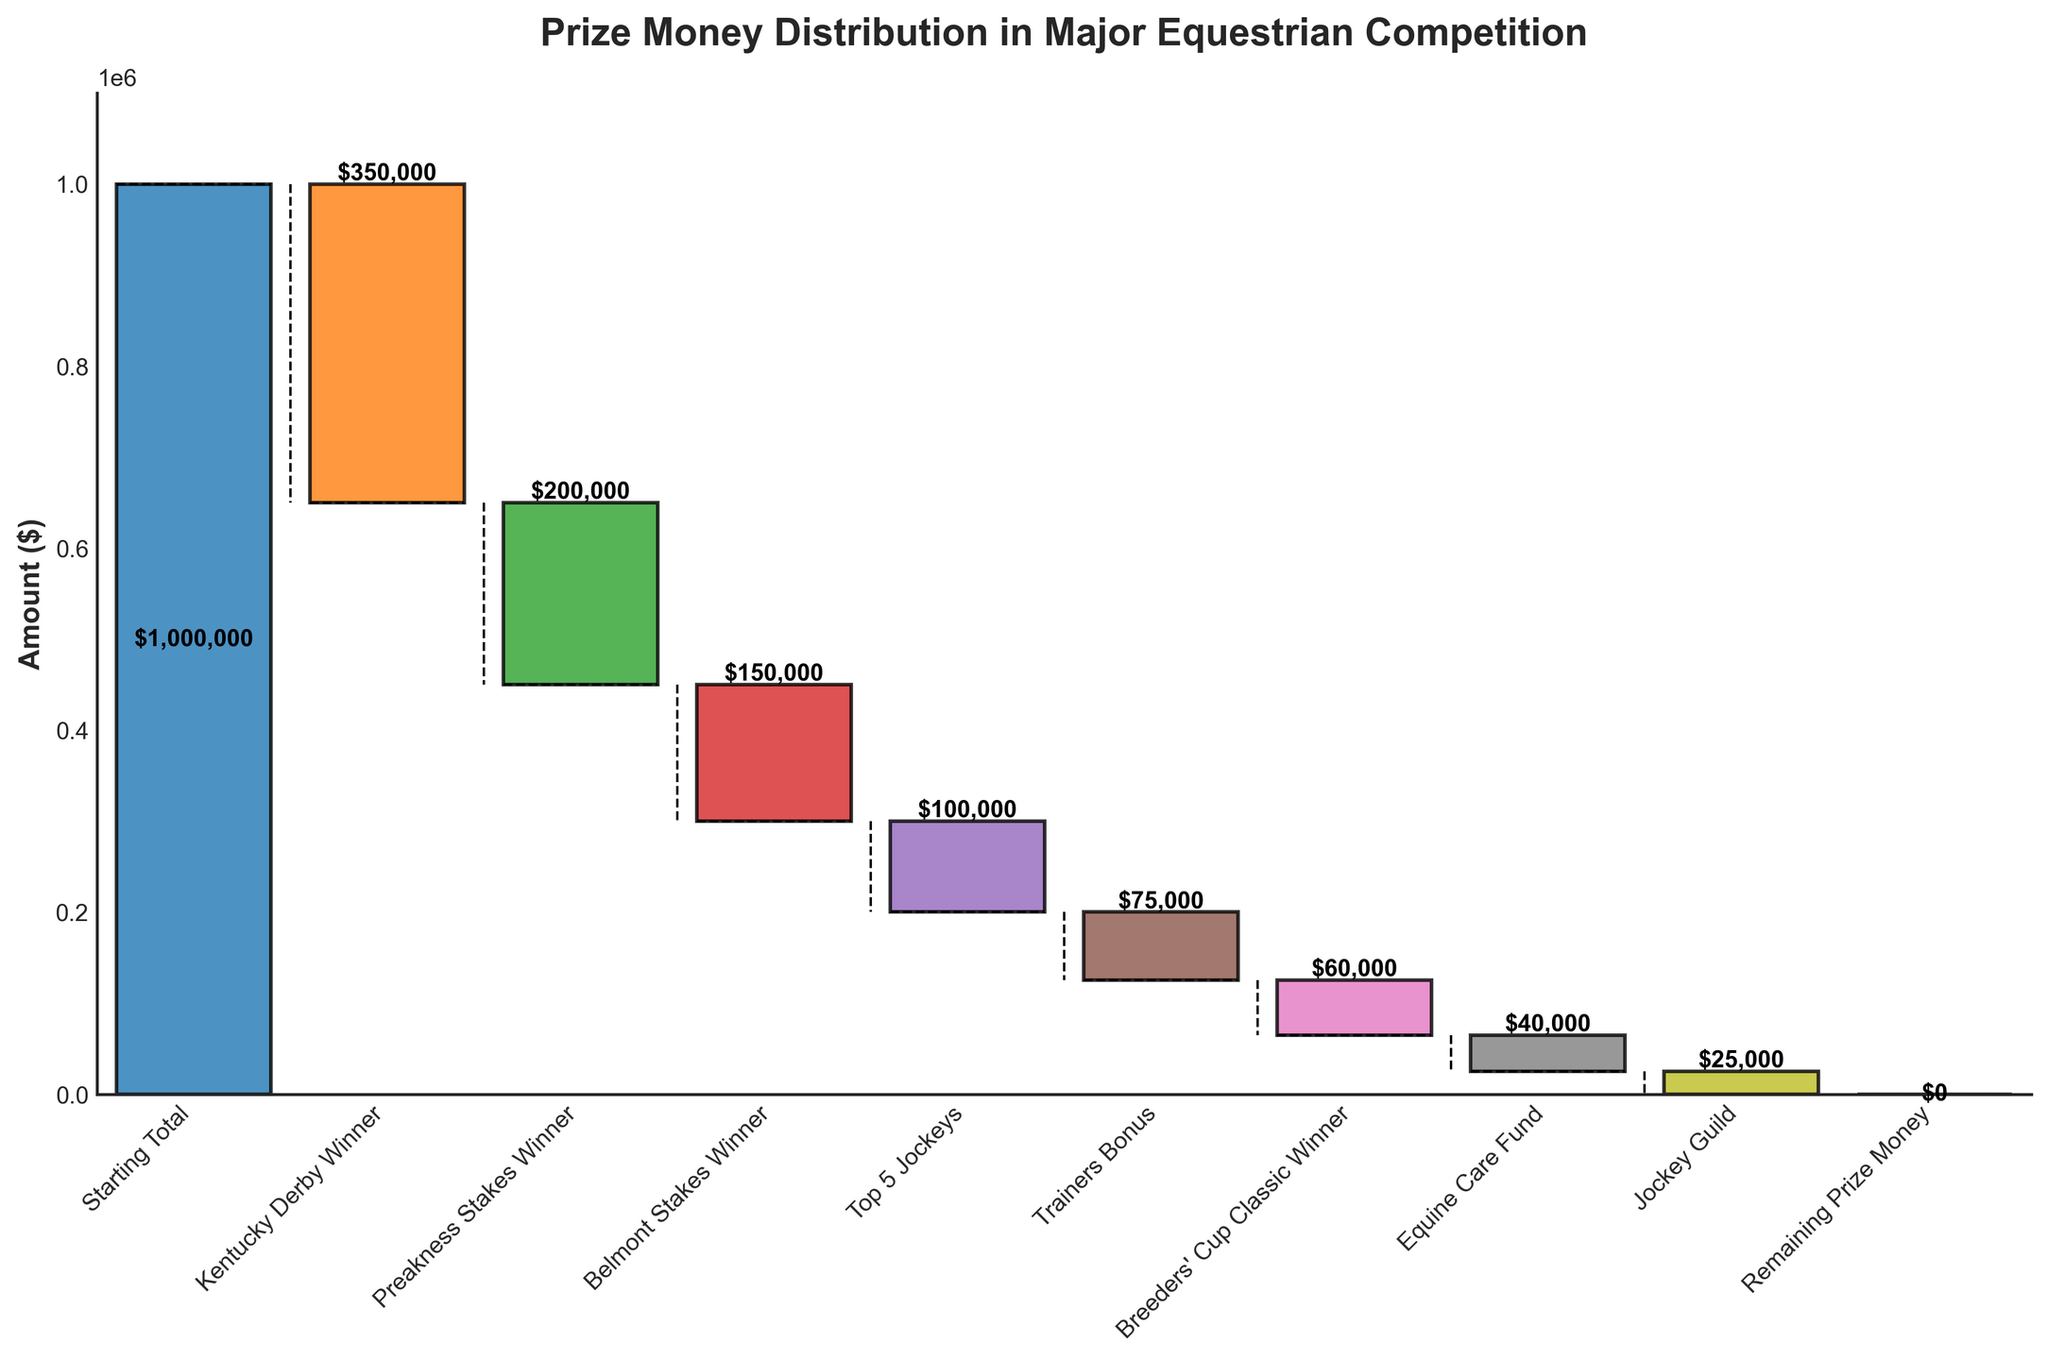How much is the total starting prize money? The title of the chart indicates it is about prize money distribution, and the first bar label "Starting Total" shows the amount.
Answer: $1,000,000 What is the amount awarded to the Belmont Stakes Winner? Look at the bar labeled "Belmont Stakes Winner"; the amount indicated on the bar is $150,000.
Answer: $150,000 Which category received the least amount of prize money? Identify the smallest bar by height and label from the chart. The "Jockey Guild" bar with the amount $25,000 is the smallest.
Answer: Jockey Guild How much total prize money is awarded to all winners combined (Kentucky Derby, Preakness Stakes, Belmont Stakes, Breeders' Cup Classic)? Sum the amounts of the bars for these categories: $350,000 + $200,000 + $150,000 + $60,000.
Answer: $760,000 How much more prize money did the Kentucky Derby Winner receive compared to the Top 5 Jockeys? Subtract the amount for Top 5 Jockeys from the Kentucky Derby Winner: $350,000 - $100,000.
Answer: $250,000 What is the cumulative amount after the Trainer's Bonus is accounted for? Sum all the amounts from the beginning up to and including the Trainer's Bonus: $1,000,000 - $350,000 - $200,000 - $150,000 - $100,000 - $75,000.
Answer: $125,000 Which categories have an equal amount of prize money distribution? Look for bars with the same height and label amounts. The chart shows "Trainers Bonus" and "Top 5 Jockeys" with close amounts but not equal; the exact match is not there.
Answer: None How much money is left for prize distribution after deducting the Equine Care Fund? After the Equine Care Fund, it brings us close to final deduction points with the calculation over cumulative sum: $1,000,000 - $350,000 - $200,000 - $150,000 - $100,000 - $75,000 - $60,000 - $40,000.
Answer: $25,000 What is the average prize money amount given out, excluding the Starting Total and Remaining Prize Money? Sum the amounts of all the deduction categories then divide by the count excluding the starting and ending points: ($350,000 + $200,000 + $150,000 + $100,000 + $75,000 + $60,000 + $40,000 + $25,000) / 8.
Answer: $125,000 Which award category contributed most to the decrease in prize money? Identify the bar with the largest absolute value of the amount. The "Kentucky Derby Winner" bar shows the highest deduction at $350,000.
Answer: Kentucky Derby Winner 